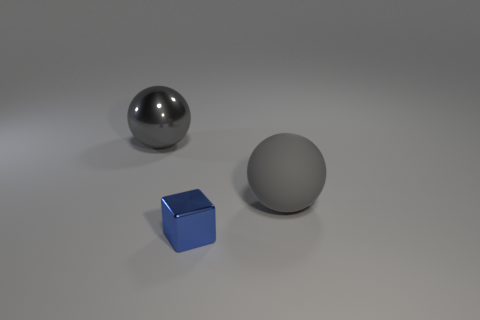There is a large matte ball; is it the same color as the big sphere that is behind the big matte object?
Offer a very short reply. Yes. What number of things are either tiny gray cubes or objects behind the shiny block?
Provide a short and direct response. 2. How many other things are the same material as the blue object?
Ensure brevity in your answer.  1. How many objects are either metal things or gray spheres?
Keep it short and to the point. 3. Is the number of small blue objects on the right side of the gray metallic ball greater than the number of spheres that are to the right of the big gray rubber ball?
Your answer should be very brief. Yes. Does the metal object that is behind the small object have the same color as the object that is right of the tiny blue metal object?
Your answer should be very brief. Yes. What size is the rubber sphere that is right of the shiny thing behind the large thing that is right of the tiny blue thing?
Provide a short and direct response. Large. The other large thing that is the same shape as the large gray metallic object is what color?
Ensure brevity in your answer.  Gray. Are there more gray objects behind the tiny shiny block than big yellow matte blocks?
Offer a terse response. Yes. Does the big metal object have the same shape as the metallic object in front of the big metal sphere?
Offer a very short reply. No. 